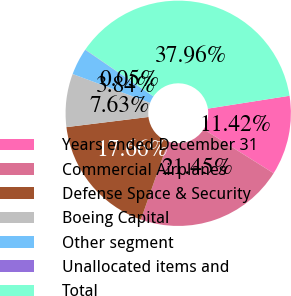<chart> <loc_0><loc_0><loc_500><loc_500><pie_chart><fcel>Years ended December 31<fcel>Commercial Airplanes<fcel>Defense Space & Security<fcel>Boeing Capital<fcel>Other segment<fcel>Unallocated items and<fcel>Total<nl><fcel>11.42%<fcel>21.45%<fcel>17.66%<fcel>7.63%<fcel>3.84%<fcel>0.05%<fcel>37.96%<nl></chart> 